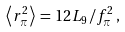Convert formula to latex. <formula><loc_0><loc_0><loc_500><loc_500>\left < r ^ { 2 } _ { \pi } \right > \, = \, 1 2 L _ { 9 } / f ^ { 2 } _ { \pi } \, ,</formula> 